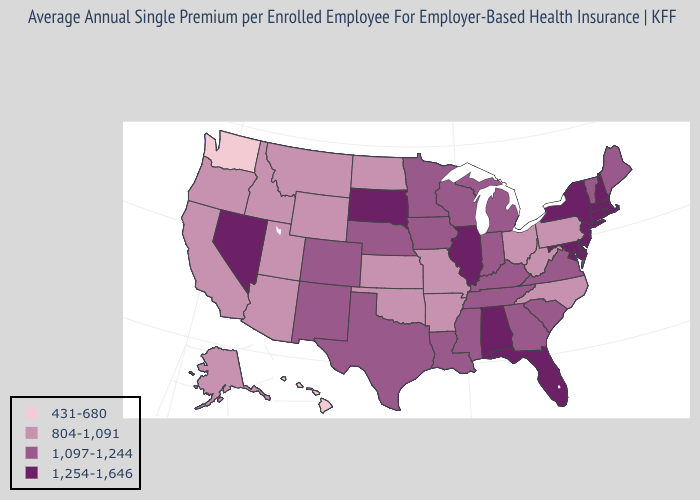Which states have the highest value in the USA?
Write a very short answer. Alabama, Connecticut, Delaware, Florida, Illinois, Maryland, Massachusetts, Nevada, New Hampshire, New Jersey, New York, Rhode Island, South Dakota. Does the first symbol in the legend represent the smallest category?
Be succinct. Yes. What is the highest value in the West ?
Give a very brief answer. 1,254-1,646. Name the states that have a value in the range 431-680?
Short answer required. Hawaii, Washington. Name the states that have a value in the range 804-1,091?
Be succinct. Alaska, Arizona, Arkansas, California, Idaho, Kansas, Missouri, Montana, North Carolina, North Dakota, Ohio, Oklahoma, Oregon, Pennsylvania, Utah, West Virginia, Wyoming. What is the value of West Virginia?
Answer briefly. 804-1,091. What is the lowest value in the MidWest?
Answer briefly. 804-1,091. What is the value of Maine?
Concise answer only. 1,097-1,244. Does Florida have a higher value than New York?
Answer briefly. No. What is the highest value in the USA?
Concise answer only. 1,254-1,646. Name the states that have a value in the range 1,254-1,646?
Be succinct. Alabama, Connecticut, Delaware, Florida, Illinois, Maryland, Massachusetts, Nevada, New Hampshire, New Jersey, New York, Rhode Island, South Dakota. Name the states that have a value in the range 431-680?
Short answer required. Hawaii, Washington. Does Oregon have the same value as Pennsylvania?
Concise answer only. Yes. Name the states that have a value in the range 1,097-1,244?
Answer briefly. Colorado, Georgia, Indiana, Iowa, Kentucky, Louisiana, Maine, Michigan, Minnesota, Mississippi, Nebraska, New Mexico, South Carolina, Tennessee, Texas, Vermont, Virginia, Wisconsin. What is the highest value in states that border Massachusetts?
Be succinct. 1,254-1,646. 